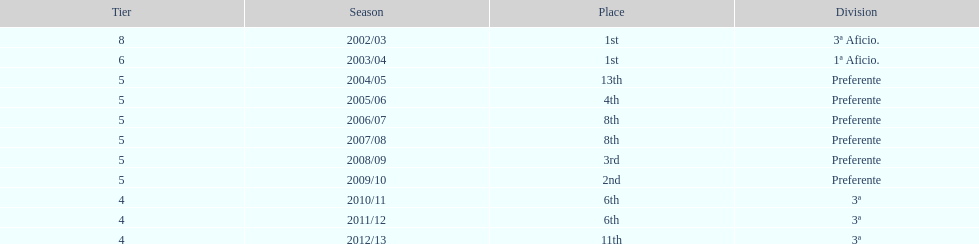What place was 1a aficio and 3a aficio? 1st. 